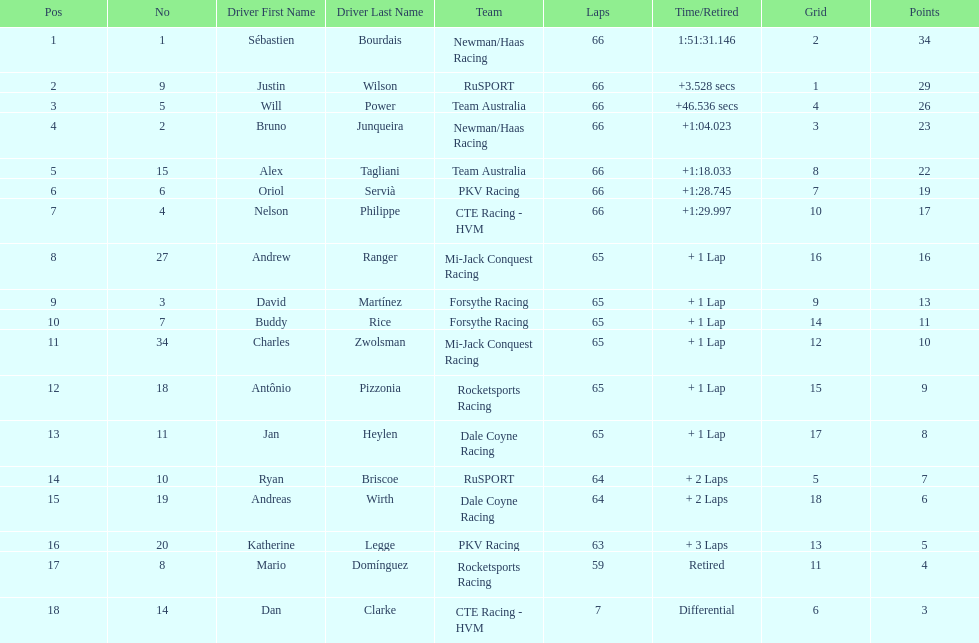Rice finished 10th. who finished next? Charles Zwolsman. 